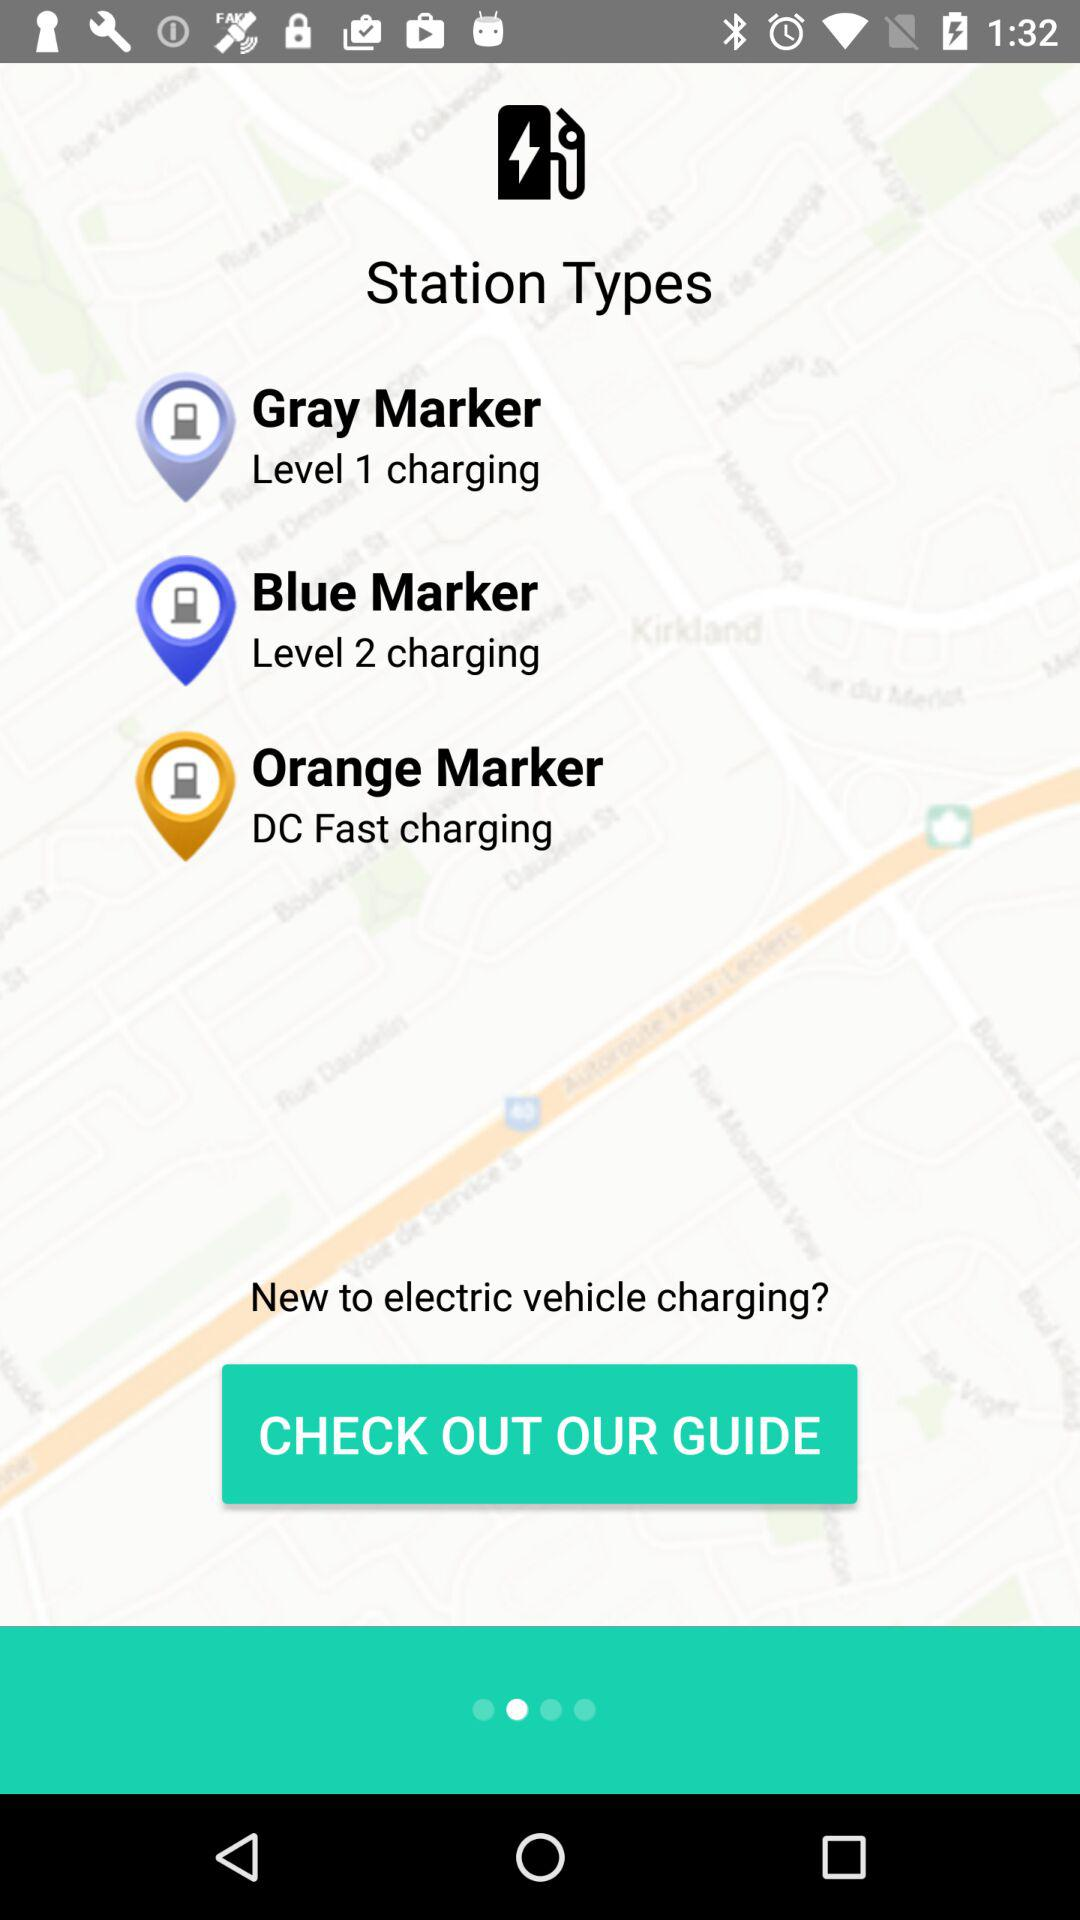What is the application name?
When the provided information is insufficient, respond with <no answer>. <no answer> 